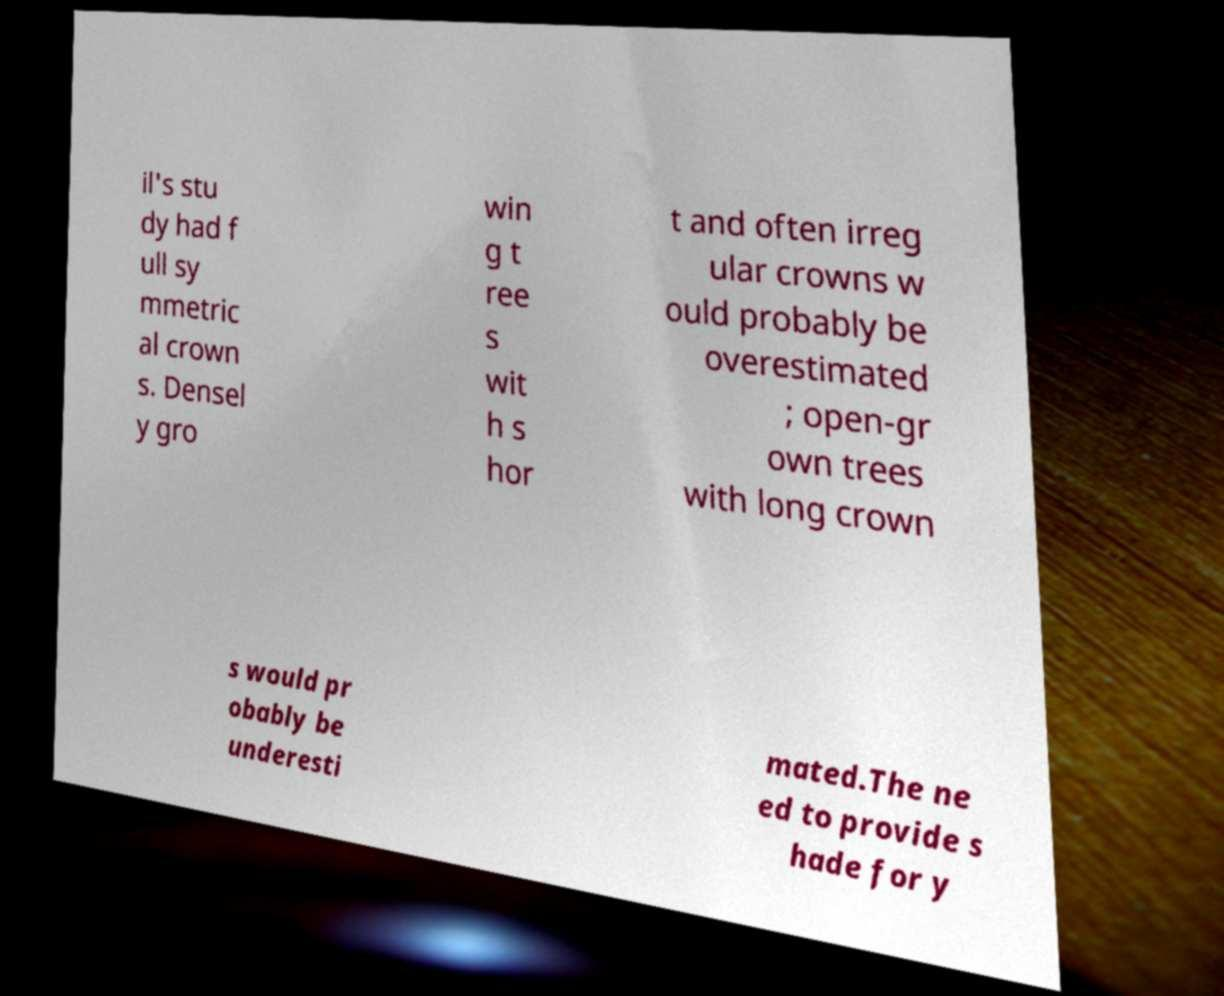Can you accurately transcribe the text from the provided image for me? il's stu dy had f ull sy mmetric al crown s. Densel y gro win g t ree s wit h s hor t and often irreg ular crowns w ould probably be overestimated ; open-gr own trees with long crown s would pr obably be underesti mated.The ne ed to provide s hade for y 